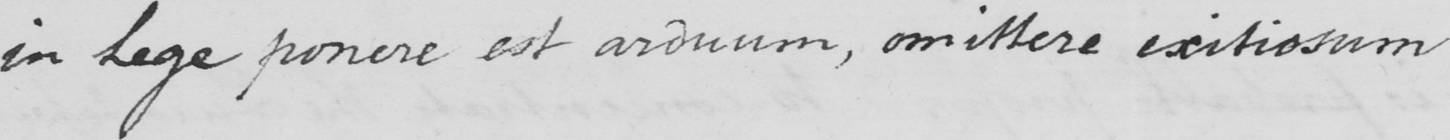What is written in this line of handwriting? in Lege ponere est arduum , omittere exitiosum 